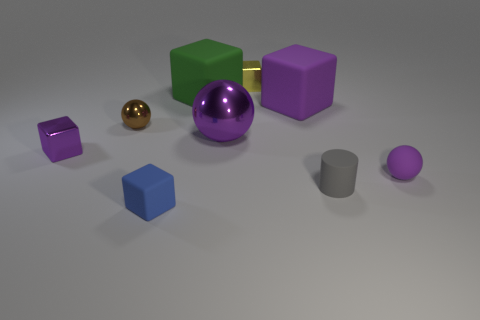Does the yellow metal block have the same size as the brown shiny thing?
Ensure brevity in your answer.  Yes. Is there any other thing that has the same shape as the green matte thing?
Give a very brief answer. Yes. How many things are either tiny metal objects that are on the left side of the small rubber cube or gray rubber cylinders?
Your answer should be very brief. 3. Is the shape of the green object the same as the small brown metallic object?
Provide a succinct answer. No. What number of other objects are there of the same size as the purple metal ball?
Your response must be concise. 2. What color is the tiny matte cube?
Give a very brief answer. Blue. What number of big objects are either cylinders or blue matte objects?
Make the answer very short. 0. There is a purple shiny thing to the left of the small blue rubber thing; does it have the same size as the metal sphere that is on the right side of the blue matte block?
Your answer should be very brief. No. The blue matte thing that is the same shape as the large purple matte object is what size?
Offer a very short reply. Small. Is the number of purple rubber cubes that are behind the big green object greater than the number of blue matte blocks that are behind the blue object?
Make the answer very short. No. 